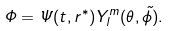<formula> <loc_0><loc_0><loc_500><loc_500>\Phi = \Psi ( t , r ^ { * } ) Y ^ { m } _ { l } ( \theta , \tilde { \phi } ) .</formula> 